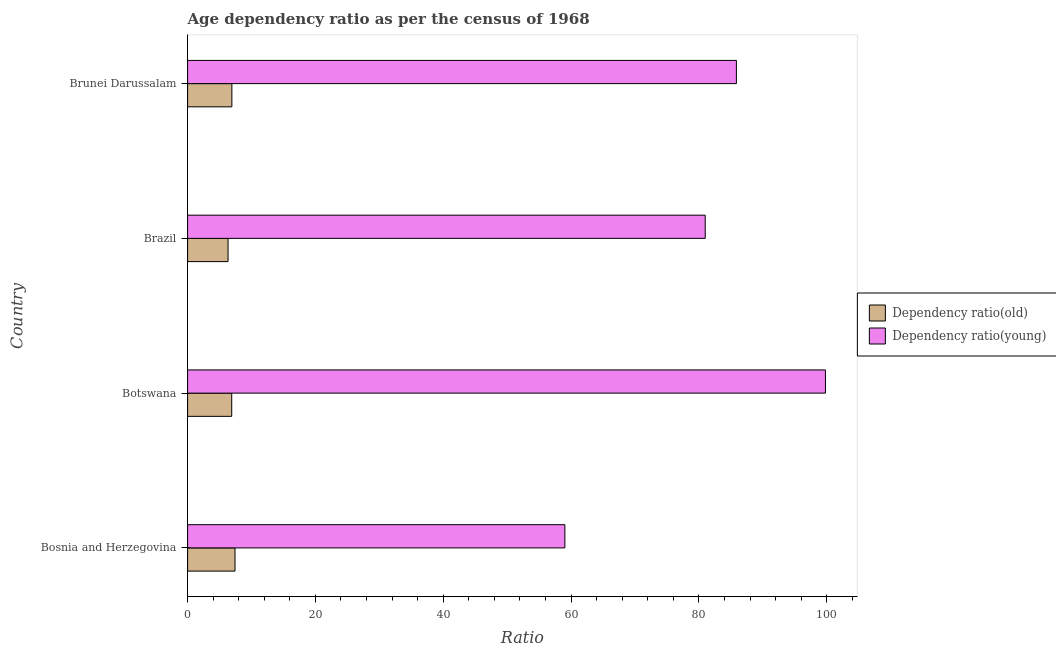How many different coloured bars are there?
Make the answer very short. 2. Are the number of bars per tick equal to the number of legend labels?
Provide a short and direct response. Yes. How many bars are there on the 2nd tick from the top?
Your response must be concise. 2. What is the label of the 2nd group of bars from the top?
Your response must be concise. Brazil. What is the age dependency ratio(young) in Bosnia and Herzegovina?
Your response must be concise. 59.03. Across all countries, what is the maximum age dependency ratio(young)?
Your answer should be compact. 99.8. Across all countries, what is the minimum age dependency ratio(old)?
Provide a succinct answer. 6.33. In which country was the age dependency ratio(young) maximum?
Your answer should be very brief. Botswana. In which country was the age dependency ratio(young) minimum?
Make the answer very short. Bosnia and Herzegovina. What is the total age dependency ratio(old) in the graph?
Provide a succinct answer. 27.58. What is the difference between the age dependency ratio(old) in Bosnia and Herzegovina and that in Brazil?
Offer a very short reply. 1.08. What is the difference between the age dependency ratio(old) in Botswana and the age dependency ratio(young) in Brunei Darussalam?
Your answer should be compact. -78.96. What is the average age dependency ratio(old) per country?
Provide a succinct answer. 6.89. What is the difference between the age dependency ratio(old) and age dependency ratio(young) in Bosnia and Herzegovina?
Offer a terse response. -51.62. In how many countries, is the age dependency ratio(young) greater than 44 ?
Your response must be concise. 4. What is the ratio of the age dependency ratio(old) in Botswana to that in Brunei Darussalam?
Provide a short and direct response. 1. Is the age dependency ratio(old) in Bosnia and Herzegovina less than that in Brazil?
Make the answer very short. No. What is the difference between the highest and the second highest age dependency ratio(young)?
Provide a succinct answer. 13.94. What is the difference between the highest and the lowest age dependency ratio(young)?
Provide a short and direct response. 40.77. What does the 1st bar from the top in Botswana represents?
Offer a terse response. Dependency ratio(young). What does the 1st bar from the bottom in Brunei Darussalam represents?
Provide a short and direct response. Dependency ratio(old). How many bars are there?
Ensure brevity in your answer.  8. How many countries are there in the graph?
Give a very brief answer. 4. Are the values on the major ticks of X-axis written in scientific E-notation?
Make the answer very short. No. Does the graph contain grids?
Your answer should be very brief. No. What is the title of the graph?
Provide a short and direct response. Age dependency ratio as per the census of 1968. What is the label or title of the X-axis?
Offer a terse response. Ratio. What is the label or title of the Y-axis?
Offer a terse response. Country. What is the Ratio in Dependency ratio(old) in Bosnia and Herzegovina?
Keep it short and to the point. 7.42. What is the Ratio in Dependency ratio(young) in Bosnia and Herzegovina?
Provide a short and direct response. 59.03. What is the Ratio of Dependency ratio(old) in Botswana?
Offer a very short reply. 6.9. What is the Ratio of Dependency ratio(young) in Botswana?
Offer a terse response. 99.8. What is the Ratio of Dependency ratio(old) in Brazil?
Offer a terse response. 6.33. What is the Ratio in Dependency ratio(young) in Brazil?
Keep it short and to the point. 80.99. What is the Ratio of Dependency ratio(old) in Brunei Darussalam?
Make the answer very short. 6.93. What is the Ratio in Dependency ratio(young) in Brunei Darussalam?
Give a very brief answer. 85.87. Across all countries, what is the maximum Ratio in Dependency ratio(old)?
Keep it short and to the point. 7.42. Across all countries, what is the maximum Ratio of Dependency ratio(young)?
Offer a terse response. 99.8. Across all countries, what is the minimum Ratio of Dependency ratio(old)?
Provide a short and direct response. 6.33. Across all countries, what is the minimum Ratio of Dependency ratio(young)?
Ensure brevity in your answer.  59.03. What is the total Ratio in Dependency ratio(old) in the graph?
Ensure brevity in your answer.  27.58. What is the total Ratio in Dependency ratio(young) in the graph?
Your answer should be very brief. 325.7. What is the difference between the Ratio of Dependency ratio(old) in Bosnia and Herzegovina and that in Botswana?
Ensure brevity in your answer.  0.51. What is the difference between the Ratio of Dependency ratio(young) in Bosnia and Herzegovina and that in Botswana?
Offer a terse response. -40.77. What is the difference between the Ratio in Dependency ratio(old) in Bosnia and Herzegovina and that in Brazil?
Offer a terse response. 1.09. What is the difference between the Ratio of Dependency ratio(young) in Bosnia and Herzegovina and that in Brazil?
Provide a short and direct response. -21.96. What is the difference between the Ratio of Dependency ratio(old) in Bosnia and Herzegovina and that in Brunei Darussalam?
Your response must be concise. 0.49. What is the difference between the Ratio of Dependency ratio(young) in Bosnia and Herzegovina and that in Brunei Darussalam?
Give a very brief answer. -26.84. What is the difference between the Ratio in Dependency ratio(old) in Botswana and that in Brazil?
Offer a very short reply. 0.57. What is the difference between the Ratio of Dependency ratio(young) in Botswana and that in Brazil?
Your response must be concise. 18.81. What is the difference between the Ratio in Dependency ratio(old) in Botswana and that in Brunei Darussalam?
Provide a short and direct response. -0.02. What is the difference between the Ratio in Dependency ratio(young) in Botswana and that in Brunei Darussalam?
Give a very brief answer. 13.94. What is the difference between the Ratio in Dependency ratio(old) in Brazil and that in Brunei Darussalam?
Provide a succinct answer. -0.6. What is the difference between the Ratio in Dependency ratio(young) in Brazil and that in Brunei Darussalam?
Ensure brevity in your answer.  -4.87. What is the difference between the Ratio in Dependency ratio(old) in Bosnia and Herzegovina and the Ratio in Dependency ratio(young) in Botswana?
Your answer should be very brief. -92.39. What is the difference between the Ratio in Dependency ratio(old) in Bosnia and Herzegovina and the Ratio in Dependency ratio(young) in Brazil?
Your answer should be very brief. -73.58. What is the difference between the Ratio of Dependency ratio(old) in Bosnia and Herzegovina and the Ratio of Dependency ratio(young) in Brunei Darussalam?
Provide a succinct answer. -78.45. What is the difference between the Ratio in Dependency ratio(old) in Botswana and the Ratio in Dependency ratio(young) in Brazil?
Your answer should be compact. -74.09. What is the difference between the Ratio in Dependency ratio(old) in Botswana and the Ratio in Dependency ratio(young) in Brunei Darussalam?
Keep it short and to the point. -78.96. What is the difference between the Ratio in Dependency ratio(old) in Brazil and the Ratio in Dependency ratio(young) in Brunei Darussalam?
Offer a very short reply. -79.54. What is the average Ratio in Dependency ratio(old) per country?
Offer a terse response. 6.89. What is the average Ratio in Dependency ratio(young) per country?
Make the answer very short. 81.42. What is the difference between the Ratio in Dependency ratio(old) and Ratio in Dependency ratio(young) in Bosnia and Herzegovina?
Provide a short and direct response. -51.62. What is the difference between the Ratio of Dependency ratio(old) and Ratio of Dependency ratio(young) in Botswana?
Offer a very short reply. -92.9. What is the difference between the Ratio in Dependency ratio(old) and Ratio in Dependency ratio(young) in Brazil?
Keep it short and to the point. -74.66. What is the difference between the Ratio in Dependency ratio(old) and Ratio in Dependency ratio(young) in Brunei Darussalam?
Ensure brevity in your answer.  -78.94. What is the ratio of the Ratio in Dependency ratio(old) in Bosnia and Herzegovina to that in Botswana?
Offer a very short reply. 1.07. What is the ratio of the Ratio in Dependency ratio(young) in Bosnia and Herzegovina to that in Botswana?
Your answer should be compact. 0.59. What is the ratio of the Ratio of Dependency ratio(old) in Bosnia and Herzegovina to that in Brazil?
Provide a succinct answer. 1.17. What is the ratio of the Ratio of Dependency ratio(young) in Bosnia and Herzegovina to that in Brazil?
Make the answer very short. 0.73. What is the ratio of the Ratio in Dependency ratio(old) in Bosnia and Herzegovina to that in Brunei Darussalam?
Your answer should be very brief. 1.07. What is the ratio of the Ratio of Dependency ratio(young) in Bosnia and Herzegovina to that in Brunei Darussalam?
Keep it short and to the point. 0.69. What is the ratio of the Ratio of Dependency ratio(old) in Botswana to that in Brazil?
Offer a very short reply. 1.09. What is the ratio of the Ratio of Dependency ratio(young) in Botswana to that in Brazil?
Offer a very short reply. 1.23. What is the ratio of the Ratio in Dependency ratio(old) in Botswana to that in Brunei Darussalam?
Give a very brief answer. 1. What is the ratio of the Ratio of Dependency ratio(young) in Botswana to that in Brunei Darussalam?
Make the answer very short. 1.16. What is the ratio of the Ratio in Dependency ratio(old) in Brazil to that in Brunei Darussalam?
Offer a very short reply. 0.91. What is the ratio of the Ratio of Dependency ratio(young) in Brazil to that in Brunei Darussalam?
Make the answer very short. 0.94. What is the difference between the highest and the second highest Ratio of Dependency ratio(old)?
Give a very brief answer. 0.49. What is the difference between the highest and the second highest Ratio in Dependency ratio(young)?
Give a very brief answer. 13.94. What is the difference between the highest and the lowest Ratio in Dependency ratio(old)?
Make the answer very short. 1.09. What is the difference between the highest and the lowest Ratio of Dependency ratio(young)?
Your answer should be compact. 40.77. 